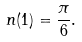Convert formula to latex. <formula><loc_0><loc_0><loc_500><loc_500>n ( 1 ) = \frac { \pi } { 6 } .</formula> 